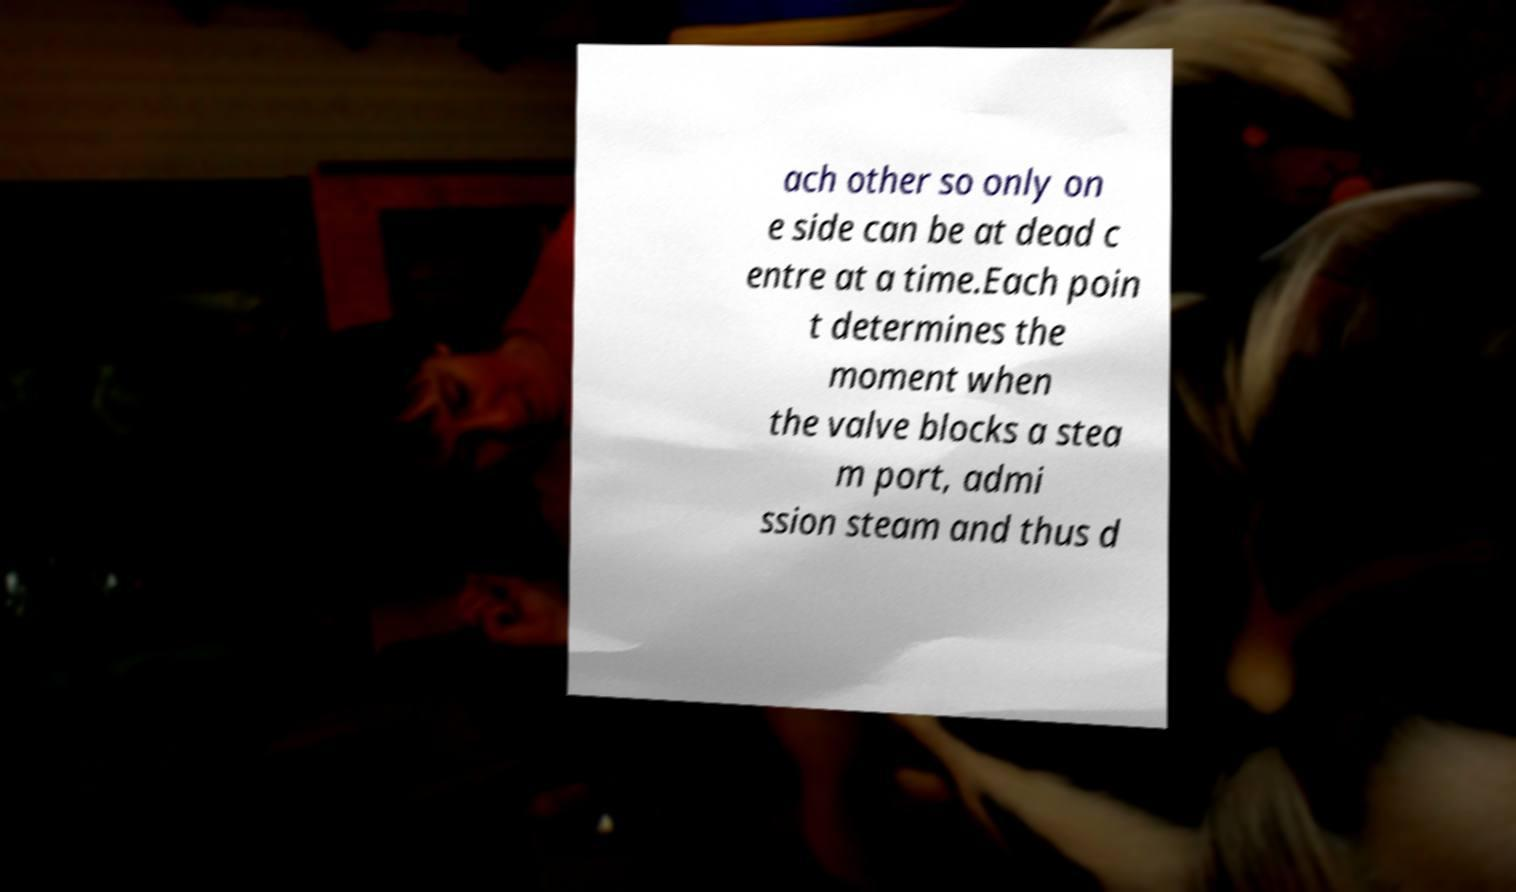Can you accurately transcribe the text from the provided image for me? ach other so only on e side can be at dead c entre at a time.Each poin t determines the moment when the valve blocks a stea m port, admi ssion steam and thus d 